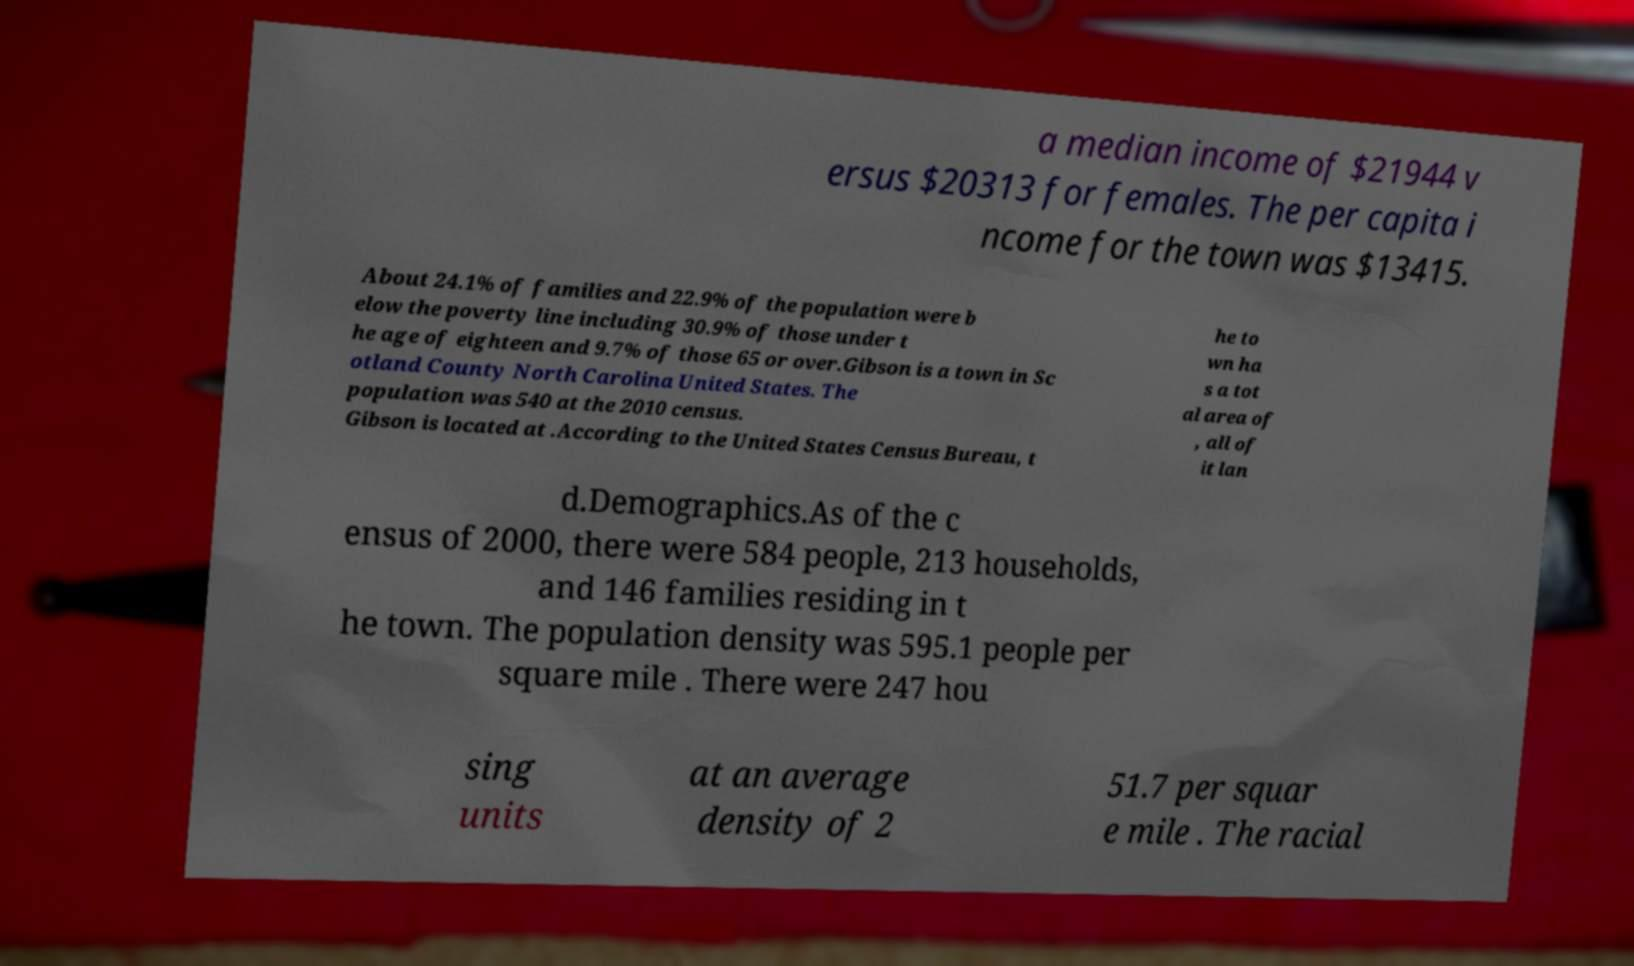There's text embedded in this image that I need extracted. Can you transcribe it verbatim? a median income of $21944 v ersus $20313 for females. The per capita i ncome for the town was $13415. About 24.1% of families and 22.9% of the population were b elow the poverty line including 30.9% of those under t he age of eighteen and 9.7% of those 65 or over.Gibson is a town in Sc otland County North Carolina United States. The population was 540 at the 2010 census. Gibson is located at .According to the United States Census Bureau, t he to wn ha s a tot al area of , all of it lan d.Demographics.As of the c ensus of 2000, there were 584 people, 213 households, and 146 families residing in t he town. The population density was 595.1 people per square mile . There were 247 hou sing units at an average density of 2 51.7 per squar e mile . The racial 